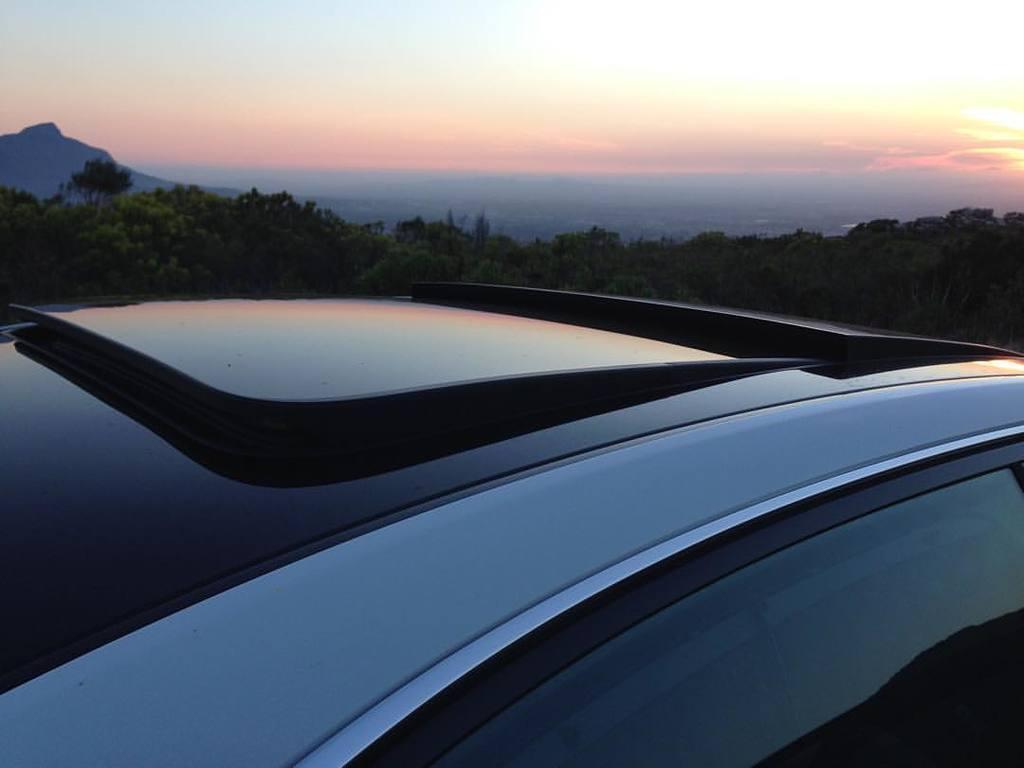Can you describe this image briefly? In this image there is a car, in the background there are trees, mountain and a sky. 